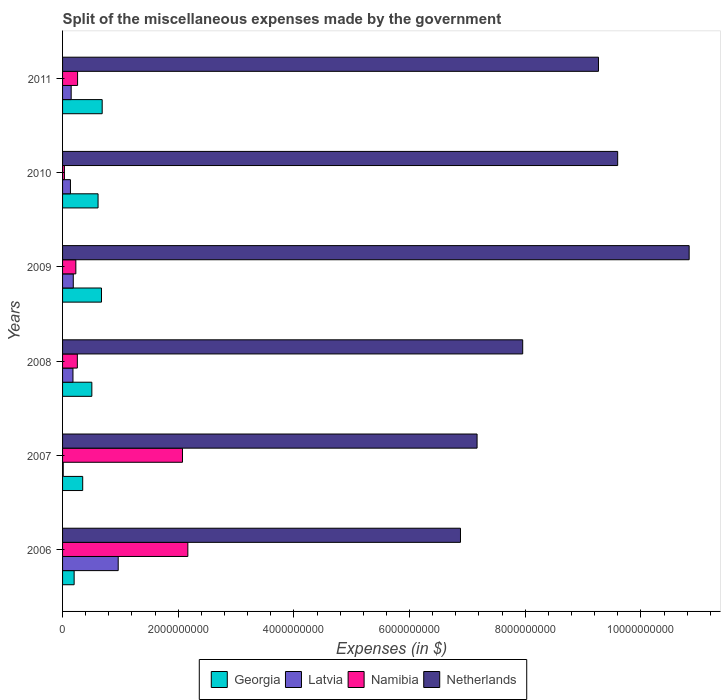How many groups of bars are there?
Your response must be concise. 6. Are the number of bars per tick equal to the number of legend labels?
Keep it short and to the point. Yes. Are the number of bars on each tick of the Y-axis equal?
Provide a succinct answer. Yes. What is the label of the 6th group of bars from the top?
Keep it short and to the point. 2006. In how many cases, is the number of bars for a given year not equal to the number of legend labels?
Your answer should be compact. 0. What is the miscellaneous expenses made by the government in Namibia in 2006?
Offer a terse response. 2.17e+09. Across all years, what is the maximum miscellaneous expenses made by the government in Netherlands?
Ensure brevity in your answer.  1.08e+1. Across all years, what is the minimum miscellaneous expenses made by the government in Netherlands?
Provide a short and direct response. 6.88e+09. In which year was the miscellaneous expenses made by the government in Latvia maximum?
Ensure brevity in your answer.  2006. What is the total miscellaneous expenses made by the government in Netherlands in the graph?
Keep it short and to the point. 5.17e+1. What is the difference between the miscellaneous expenses made by the government in Georgia in 2006 and that in 2008?
Your answer should be very brief. -3.06e+08. What is the difference between the miscellaneous expenses made by the government in Namibia in 2009 and the miscellaneous expenses made by the government in Latvia in 2007?
Your answer should be very brief. 2.18e+08. What is the average miscellaneous expenses made by the government in Georgia per year?
Offer a terse response. 5.04e+08. In the year 2009, what is the difference between the miscellaneous expenses made by the government in Georgia and miscellaneous expenses made by the government in Netherlands?
Give a very brief answer. -1.02e+1. In how many years, is the miscellaneous expenses made by the government in Georgia greater than 6400000000 $?
Offer a very short reply. 0. What is the ratio of the miscellaneous expenses made by the government in Latvia in 2006 to that in 2010?
Keep it short and to the point. 7.06. Is the miscellaneous expenses made by the government in Georgia in 2008 less than that in 2009?
Offer a very short reply. Yes. Is the difference between the miscellaneous expenses made by the government in Georgia in 2010 and 2011 greater than the difference between the miscellaneous expenses made by the government in Netherlands in 2010 and 2011?
Give a very brief answer. No. What is the difference between the highest and the second highest miscellaneous expenses made by the government in Namibia?
Keep it short and to the point. 9.26e+07. What is the difference between the highest and the lowest miscellaneous expenses made by the government in Namibia?
Provide a succinct answer. 2.13e+09. In how many years, is the miscellaneous expenses made by the government in Georgia greater than the average miscellaneous expenses made by the government in Georgia taken over all years?
Your answer should be compact. 4. What does the 4th bar from the top in 2010 represents?
Your response must be concise. Georgia. What does the 3rd bar from the bottom in 2011 represents?
Your answer should be very brief. Namibia. Is it the case that in every year, the sum of the miscellaneous expenses made by the government in Latvia and miscellaneous expenses made by the government in Georgia is greater than the miscellaneous expenses made by the government in Namibia?
Your response must be concise. No. How many bars are there?
Make the answer very short. 24. Are all the bars in the graph horizontal?
Offer a terse response. Yes. How many years are there in the graph?
Offer a very short reply. 6. What is the difference between two consecutive major ticks on the X-axis?
Keep it short and to the point. 2.00e+09. Where does the legend appear in the graph?
Make the answer very short. Bottom center. How many legend labels are there?
Offer a terse response. 4. How are the legend labels stacked?
Give a very brief answer. Horizontal. What is the title of the graph?
Your response must be concise. Split of the miscellaneous expenses made by the government. Does "New Caledonia" appear as one of the legend labels in the graph?
Make the answer very short. No. What is the label or title of the X-axis?
Provide a succinct answer. Expenses (in $). What is the label or title of the Y-axis?
Provide a succinct answer. Years. What is the Expenses (in $) in Georgia in 2006?
Keep it short and to the point. 2.00e+08. What is the Expenses (in $) in Latvia in 2006?
Ensure brevity in your answer.  9.62e+08. What is the Expenses (in $) in Namibia in 2006?
Keep it short and to the point. 2.17e+09. What is the Expenses (in $) in Netherlands in 2006?
Ensure brevity in your answer.  6.88e+09. What is the Expenses (in $) of Georgia in 2007?
Your answer should be very brief. 3.48e+08. What is the Expenses (in $) in Latvia in 2007?
Your answer should be very brief. 1.14e+07. What is the Expenses (in $) of Namibia in 2007?
Offer a terse response. 2.07e+09. What is the Expenses (in $) in Netherlands in 2007?
Offer a very short reply. 7.17e+09. What is the Expenses (in $) in Georgia in 2008?
Offer a terse response. 5.06e+08. What is the Expenses (in $) in Latvia in 2008?
Give a very brief answer. 1.80e+08. What is the Expenses (in $) in Namibia in 2008?
Provide a short and direct response. 2.55e+08. What is the Expenses (in $) in Netherlands in 2008?
Ensure brevity in your answer.  7.96e+09. What is the Expenses (in $) of Georgia in 2009?
Offer a very short reply. 6.73e+08. What is the Expenses (in $) of Latvia in 2009?
Your answer should be very brief. 1.85e+08. What is the Expenses (in $) in Namibia in 2009?
Your answer should be compact. 2.30e+08. What is the Expenses (in $) in Netherlands in 2009?
Ensure brevity in your answer.  1.08e+1. What is the Expenses (in $) of Georgia in 2010?
Provide a succinct answer. 6.14e+08. What is the Expenses (in $) of Latvia in 2010?
Ensure brevity in your answer.  1.36e+08. What is the Expenses (in $) of Namibia in 2010?
Your response must be concise. 3.22e+07. What is the Expenses (in $) of Netherlands in 2010?
Provide a succinct answer. 9.60e+09. What is the Expenses (in $) in Georgia in 2011?
Provide a succinct answer. 6.85e+08. What is the Expenses (in $) of Latvia in 2011?
Your answer should be compact. 1.49e+08. What is the Expenses (in $) of Namibia in 2011?
Offer a terse response. 2.60e+08. What is the Expenses (in $) of Netherlands in 2011?
Offer a very short reply. 9.27e+09. Across all years, what is the maximum Expenses (in $) of Georgia?
Give a very brief answer. 6.85e+08. Across all years, what is the maximum Expenses (in $) in Latvia?
Give a very brief answer. 9.62e+08. Across all years, what is the maximum Expenses (in $) in Namibia?
Give a very brief answer. 2.17e+09. Across all years, what is the maximum Expenses (in $) of Netherlands?
Provide a short and direct response. 1.08e+1. Across all years, what is the minimum Expenses (in $) in Georgia?
Your response must be concise. 2.00e+08. Across all years, what is the minimum Expenses (in $) of Latvia?
Provide a succinct answer. 1.14e+07. Across all years, what is the minimum Expenses (in $) in Namibia?
Offer a very short reply. 3.22e+07. Across all years, what is the minimum Expenses (in $) in Netherlands?
Provide a short and direct response. 6.88e+09. What is the total Expenses (in $) of Georgia in the graph?
Ensure brevity in your answer.  3.03e+09. What is the total Expenses (in $) of Latvia in the graph?
Give a very brief answer. 1.62e+09. What is the total Expenses (in $) in Namibia in the graph?
Your response must be concise. 5.02e+09. What is the total Expenses (in $) in Netherlands in the graph?
Keep it short and to the point. 5.17e+1. What is the difference between the Expenses (in $) of Georgia in 2006 and that in 2007?
Offer a very short reply. -1.48e+08. What is the difference between the Expenses (in $) in Latvia in 2006 and that in 2007?
Give a very brief answer. 9.51e+08. What is the difference between the Expenses (in $) of Namibia in 2006 and that in 2007?
Provide a short and direct response. 9.26e+07. What is the difference between the Expenses (in $) in Netherlands in 2006 and that in 2007?
Your answer should be compact. -2.87e+08. What is the difference between the Expenses (in $) in Georgia in 2006 and that in 2008?
Keep it short and to the point. -3.06e+08. What is the difference between the Expenses (in $) in Latvia in 2006 and that in 2008?
Ensure brevity in your answer.  7.82e+08. What is the difference between the Expenses (in $) of Namibia in 2006 and that in 2008?
Your answer should be compact. 1.91e+09. What is the difference between the Expenses (in $) of Netherlands in 2006 and that in 2008?
Give a very brief answer. -1.08e+09. What is the difference between the Expenses (in $) in Georgia in 2006 and that in 2009?
Offer a terse response. -4.73e+08. What is the difference between the Expenses (in $) of Latvia in 2006 and that in 2009?
Keep it short and to the point. 7.77e+08. What is the difference between the Expenses (in $) in Namibia in 2006 and that in 2009?
Your answer should be compact. 1.94e+09. What is the difference between the Expenses (in $) of Netherlands in 2006 and that in 2009?
Your answer should be very brief. -3.95e+09. What is the difference between the Expenses (in $) of Georgia in 2006 and that in 2010?
Offer a terse response. -4.14e+08. What is the difference between the Expenses (in $) in Latvia in 2006 and that in 2010?
Provide a short and direct response. 8.26e+08. What is the difference between the Expenses (in $) of Namibia in 2006 and that in 2010?
Give a very brief answer. 2.13e+09. What is the difference between the Expenses (in $) in Netherlands in 2006 and that in 2010?
Offer a terse response. -2.72e+09. What is the difference between the Expenses (in $) in Georgia in 2006 and that in 2011?
Ensure brevity in your answer.  -4.85e+08. What is the difference between the Expenses (in $) in Latvia in 2006 and that in 2011?
Offer a terse response. 8.13e+08. What is the difference between the Expenses (in $) in Namibia in 2006 and that in 2011?
Your answer should be compact. 1.91e+09. What is the difference between the Expenses (in $) in Netherlands in 2006 and that in 2011?
Keep it short and to the point. -2.39e+09. What is the difference between the Expenses (in $) in Georgia in 2007 and that in 2008?
Your response must be concise. -1.58e+08. What is the difference between the Expenses (in $) of Latvia in 2007 and that in 2008?
Ensure brevity in your answer.  -1.69e+08. What is the difference between the Expenses (in $) of Namibia in 2007 and that in 2008?
Provide a succinct answer. 1.82e+09. What is the difference between the Expenses (in $) of Netherlands in 2007 and that in 2008?
Give a very brief answer. -7.89e+08. What is the difference between the Expenses (in $) of Georgia in 2007 and that in 2009?
Keep it short and to the point. -3.25e+08. What is the difference between the Expenses (in $) of Latvia in 2007 and that in 2009?
Ensure brevity in your answer.  -1.74e+08. What is the difference between the Expenses (in $) of Namibia in 2007 and that in 2009?
Your response must be concise. 1.84e+09. What is the difference between the Expenses (in $) of Netherlands in 2007 and that in 2009?
Provide a succinct answer. -3.67e+09. What is the difference between the Expenses (in $) of Georgia in 2007 and that in 2010?
Your answer should be very brief. -2.66e+08. What is the difference between the Expenses (in $) of Latvia in 2007 and that in 2010?
Your response must be concise. -1.25e+08. What is the difference between the Expenses (in $) of Namibia in 2007 and that in 2010?
Offer a terse response. 2.04e+09. What is the difference between the Expenses (in $) in Netherlands in 2007 and that in 2010?
Your response must be concise. -2.43e+09. What is the difference between the Expenses (in $) of Georgia in 2007 and that in 2011?
Keep it short and to the point. -3.37e+08. What is the difference between the Expenses (in $) in Latvia in 2007 and that in 2011?
Provide a succinct answer. -1.37e+08. What is the difference between the Expenses (in $) of Namibia in 2007 and that in 2011?
Your response must be concise. 1.81e+09. What is the difference between the Expenses (in $) in Netherlands in 2007 and that in 2011?
Provide a succinct answer. -2.10e+09. What is the difference between the Expenses (in $) of Georgia in 2008 and that in 2009?
Make the answer very short. -1.67e+08. What is the difference between the Expenses (in $) in Latvia in 2008 and that in 2009?
Keep it short and to the point. -5.15e+06. What is the difference between the Expenses (in $) in Namibia in 2008 and that in 2009?
Your response must be concise. 2.59e+07. What is the difference between the Expenses (in $) of Netherlands in 2008 and that in 2009?
Offer a terse response. -2.88e+09. What is the difference between the Expenses (in $) in Georgia in 2008 and that in 2010?
Keep it short and to the point. -1.08e+08. What is the difference between the Expenses (in $) in Latvia in 2008 and that in 2010?
Offer a terse response. 4.36e+07. What is the difference between the Expenses (in $) of Namibia in 2008 and that in 2010?
Provide a short and direct response. 2.23e+08. What is the difference between the Expenses (in $) in Netherlands in 2008 and that in 2010?
Ensure brevity in your answer.  -1.64e+09. What is the difference between the Expenses (in $) of Georgia in 2008 and that in 2011?
Your answer should be very brief. -1.79e+08. What is the difference between the Expenses (in $) in Latvia in 2008 and that in 2011?
Provide a short and direct response. 3.12e+07. What is the difference between the Expenses (in $) of Namibia in 2008 and that in 2011?
Keep it short and to the point. -4.06e+06. What is the difference between the Expenses (in $) of Netherlands in 2008 and that in 2011?
Offer a terse response. -1.31e+09. What is the difference between the Expenses (in $) in Georgia in 2009 and that in 2010?
Ensure brevity in your answer.  5.92e+07. What is the difference between the Expenses (in $) of Latvia in 2009 and that in 2010?
Keep it short and to the point. 4.88e+07. What is the difference between the Expenses (in $) in Namibia in 2009 and that in 2010?
Your response must be concise. 1.97e+08. What is the difference between the Expenses (in $) in Netherlands in 2009 and that in 2010?
Ensure brevity in your answer.  1.24e+09. What is the difference between the Expenses (in $) in Georgia in 2009 and that in 2011?
Offer a very short reply. -1.21e+07. What is the difference between the Expenses (in $) in Latvia in 2009 and that in 2011?
Offer a terse response. 3.63e+07. What is the difference between the Expenses (in $) in Namibia in 2009 and that in 2011?
Your response must be concise. -2.99e+07. What is the difference between the Expenses (in $) of Netherlands in 2009 and that in 2011?
Give a very brief answer. 1.57e+09. What is the difference between the Expenses (in $) of Georgia in 2010 and that in 2011?
Your answer should be very brief. -7.13e+07. What is the difference between the Expenses (in $) of Latvia in 2010 and that in 2011?
Offer a terse response. -1.25e+07. What is the difference between the Expenses (in $) of Namibia in 2010 and that in 2011?
Keep it short and to the point. -2.27e+08. What is the difference between the Expenses (in $) of Netherlands in 2010 and that in 2011?
Offer a very short reply. 3.32e+08. What is the difference between the Expenses (in $) of Georgia in 2006 and the Expenses (in $) of Latvia in 2007?
Your response must be concise. 1.89e+08. What is the difference between the Expenses (in $) of Georgia in 2006 and the Expenses (in $) of Namibia in 2007?
Offer a terse response. -1.87e+09. What is the difference between the Expenses (in $) in Georgia in 2006 and the Expenses (in $) in Netherlands in 2007?
Keep it short and to the point. -6.97e+09. What is the difference between the Expenses (in $) in Latvia in 2006 and the Expenses (in $) in Namibia in 2007?
Your response must be concise. -1.11e+09. What is the difference between the Expenses (in $) in Latvia in 2006 and the Expenses (in $) in Netherlands in 2007?
Provide a succinct answer. -6.20e+09. What is the difference between the Expenses (in $) in Namibia in 2006 and the Expenses (in $) in Netherlands in 2007?
Provide a succinct answer. -5.00e+09. What is the difference between the Expenses (in $) in Georgia in 2006 and the Expenses (in $) in Namibia in 2008?
Offer a very short reply. -5.55e+07. What is the difference between the Expenses (in $) in Georgia in 2006 and the Expenses (in $) in Netherlands in 2008?
Offer a terse response. -7.76e+09. What is the difference between the Expenses (in $) in Latvia in 2006 and the Expenses (in $) in Namibia in 2008?
Your response must be concise. 7.07e+08. What is the difference between the Expenses (in $) of Latvia in 2006 and the Expenses (in $) of Netherlands in 2008?
Your response must be concise. -6.99e+09. What is the difference between the Expenses (in $) in Namibia in 2006 and the Expenses (in $) in Netherlands in 2008?
Offer a terse response. -5.79e+09. What is the difference between the Expenses (in $) in Georgia in 2006 and the Expenses (in $) in Latvia in 2009?
Give a very brief answer. 1.49e+07. What is the difference between the Expenses (in $) of Georgia in 2006 and the Expenses (in $) of Namibia in 2009?
Your response must be concise. -2.96e+07. What is the difference between the Expenses (in $) of Georgia in 2006 and the Expenses (in $) of Netherlands in 2009?
Your answer should be compact. -1.06e+1. What is the difference between the Expenses (in $) of Latvia in 2006 and the Expenses (in $) of Namibia in 2009?
Provide a short and direct response. 7.33e+08. What is the difference between the Expenses (in $) in Latvia in 2006 and the Expenses (in $) in Netherlands in 2009?
Your answer should be compact. -9.87e+09. What is the difference between the Expenses (in $) of Namibia in 2006 and the Expenses (in $) of Netherlands in 2009?
Your response must be concise. -8.67e+09. What is the difference between the Expenses (in $) in Georgia in 2006 and the Expenses (in $) in Latvia in 2010?
Your answer should be compact. 6.36e+07. What is the difference between the Expenses (in $) in Georgia in 2006 and the Expenses (in $) in Namibia in 2010?
Provide a succinct answer. 1.68e+08. What is the difference between the Expenses (in $) of Georgia in 2006 and the Expenses (in $) of Netherlands in 2010?
Offer a very short reply. -9.40e+09. What is the difference between the Expenses (in $) of Latvia in 2006 and the Expenses (in $) of Namibia in 2010?
Offer a terse response. 9.30e+08. What is the difference between the Expenses (in $) of Latvia in 2006 and the Expenses (in $) of Netherlands in 2010?
Make the answer very short. -8.64e+09. What is the difference between the Expenses (in $) in Namibia in 2006 and the Expenses (in $) in Netherlands in 2010?
Your response must be concise. -7.43e+09. What is the difference between the Expenses (in $) in Georgia in 2006 and the Expenses (in $) in Latvia in 2011?
Your response must be concise. 5.12e+07. What is the difference between the Expenses (in $) of Georgia in 2006 and the Expenses (in $) of Namibia in 2011?
Offer a terse response. -5.95e+07. What is the difference between the Expenses (in $) in Georgia in 2006 and the Expenses (in $) in Netherlands in 2011?
Your answer should be compact. -9.07e+09. What is the difference between the Expenses (in $) in Latvia in 2006 and the Expenses (in $) in Namibia in 2011?
Your answer should be very brief. 7.03e+08. What is the difference between the Expenses (in $) in Latvia in 2006 and the Expenses (in $) in Netherlands in 2011?
Your answer should be very brief. -8.30e+09. What is the difference between the Expenses (in $) in Namibia in 2006 and the Expenses (in $) in Netherlands in 2011?
Your answer should be compact. -7.10e+09. What is the difference between the Expenses (in $) in Georgia in 2007 and the Expenses (in $) in Latvia in 2008?
Provide a succinct answer. 1.68e+08. What is the difference between the Expenses (in $) in Georgia in 2007 and the Expenses (in $) in Namibia in 2008?
Keep it short and to the point. 9.27e+07. What is the difference between the Expenses (in $) of Georgia in 2007 and the Expenses (in $) of Netherlands in 2008?
Your response must be concise. -7.61e+09. What is the difference between the Expenses (in $) in Latvia in 2007 and the Expenses (in $) in Namibia in 2008?
Provide a succinct answer. -2.44e+08. What is the difference between the Expenses (in $) of Latvia in 2007 and the Expenses (in $) of Netherlands in 2008?
Ensure brevity in your answer.  -7.94e+09. What is the difference between the Expenses (in $) in Namibia in 2007 and the Expenses (in $) in Netherlands in 2008?
Your answer should be very brief. -5.88e+09. What is the difference between the Expenses (in $) of Georgia in 2007 and the Expenses (in $) of Latvia in 2009?
Make the answer very short. 1.63e+08. What is the difference between the Expenses (in $) in Georgia in 2007 and the Expenses (in $) in Namibia in 2009?
Give a very brief answer. 1.19e+08. What is the difference between the Expenses (in $) of Georgia in 2007 and the Expenses (in $) of Netherlands in 2009?
Ensure brevity in your answer.  -1.05e+1. What is the difference between the Expenses (in $) in Latvia in 2007 and the Expenses (in $) in Namibia in 2009?
Provide a succinct answer. -2.18e+08. What is the difference between the Expenses (in $) of Latvia in 2007 and the Expenses (in $) of Netherlands in 2009?
Your response must be concise. -1.08e+1. What is the difference between the Expenses (in $) in Namibia in 2007 and the Expenses (in $) in Netherlands in 2009?
Provide a short and direct response. -8.76e+09. What is the difference between the Expenses (in $) of Georgia in 2007 and the Expenses (in $) of Latvia in 2010?
Make the answer very short. 2.12e+08. What is the difference between the Expenses (in $) in Georgia in 2007 and the Expenses (in $) in Namibia in 2010?
Keep it short and to the point. 3.16e+08. What is the difference between the Expenses (in $) of Georgia in 2007 and the Expenses (in $) of Netherlands in 2010?
Offer a very short reply. -9.25e+09. What is the difference between the Expenses (in $) in Latvia in 2007 and the Expenses (in $) in Namibia in 2010?
Give a very brief answer. -2.08e+07. What is the difference between the Expenses (in $) of Latvia in 2007 and the Expenses (in $) of Netherlands in 2010?
Provide a succinct answer. -9.59e+09. What is the difference between the Expenses (in $) in Namibia in 2007 and the Expenses (in $) in Netherlands in 2010?
Give a very brief answer. -7.52e+09. What is the difference between the Expenses (in $) in Georgia in 2007 and the Expenses (in $) in Latvia in 2011?
Make the answer very short. 1.99e+08. What is the difference between the Expenses (in $) in Georgia in 2007 and the Expenses (in $) in Namibia in 2011?
Your answer should be very brief. 8.87e+07. What is the difference between the Expenses (in $) of Georgia in 2007 and the Expenses (in $) of Netherlands in 2011?
Your answer should be compact. -8.92e+09. What is the difference between the Expenses (in $) of Latvia in 2007 and the Expenses (in $) of Namibia in 2011?
Provide a succinct answer. -2.48e+08. What is the difference between the Expenses (in $) of Latvia in 2007 and the Expenses (in $) of Netherlands in 2011?
Provide a succinct answer. -9.25e+09. What is the difference between the Expenses (in $) of Namibia in 2007 and the Expenses (in $) of Netherlands in 2011?
Your answer should be very brief. -7.19e+09. What is the difference between the Expenses (in $) of Georgia in 2008 and the Expenses (in $) of Latvia in 2009?
Provide a succinct answer. 3.21e+08. What is the difference between the Expenses (in $) in Georgia in 2008 and the Expenses (in $) in Namibia in 2009?
Ensure brevity in your answer.  2.77e+08. What is the difference between the Expenses (in $) in Georgia in 2008 and the Expenses (in $) in Netherlands in 2009?
Ensure brevity in your answer.  -1.03e+1. What is the difference between the Expenses (in $) in Latvia in 2008 and the Expenses (in $) in Namibia in 2009?
Offer a very short reply. -4.96e+07. What is the difference between the Expenses (in $) of Latvia in 2008 and the Expenses (in $) of Netherlands in 2009?
Provide a succinct answer. -1.07e+1. What is the difference between the Expenses (in $) of Namibia in 2008 and the Expenses (in $) of Netherlands in 2009?
Offer a terse response. -1.06e+1. What is the difference between the Expenses (in $) of Georgia in 2008 and the Expenses (in $) of Latvia in 2010?
Your answer should be compact. 3.70e+08. What is the difference between the Expenses (in $) in Georgia in 2008 and the Expenses (in $) in Namibia in 2010?
Keep it short and to the point. 4.74e+08. What is the difference between the Expenses (in $) of Georgia in 2008 and the Expenses (in $) of Netherlands in 2010?
Your answer should be very brief. -9.09e+09. What is the difference between the Expenses (in $) in Latvia in 2008 and the Expenses (in $) in Namibia in 2010?
Ensure brevity in your answer.  1.48e+08. What is the difference between the Expenses (in $) of Latvia in 2008 and the Expenses (in $) of Netherlands in 2010?
Keep it short and to the point. -9.42e+09. What is the difference between the Expenses (in $) in Namibia in 2008 and the Expenses (in $) in Netherlands in 2010?
Provide a succinct answer. -9.34e+09. What is the difference between the Expenses (in $) in Georgia in 2008 and the Expenses (in $) in Latvia in 2011?
Offer a terse response. 3.57e+08. What is the difference between the Expenses (in $) of Georgia in 2008 and the Expenses (in $) of Namibia in 2011?
Your answer should be very brief. 2.47e+08. What is the difference between the Expenses (in $) in Georgia in 2008 and the Expenses (in $) in Netherlands in 2011?
Provide a short and direct response. -8.76e+09. What is the difference between the Expenses (in $) of Latvia in 2008 and the Expenses (in $) of Namibia in 2011?
Ensure brevity in your answer.  -7.95e+07. What is the difference between the Expenses (in $) of Latvia in 2008 and the Expenses (in $) of Netherlands in 2011?
Keep it short and to the point. -9.09e+09. What is the difference between the Expenses (in $) in Namibia in 2008 and the Expenses (in $) in Netherlands in 2011?
Ensure brevity in your answer.  -9.01e+09. What is the difference between the Expenses (in $) of Georgia in 2009 and the Expenses (in $) of Latvia in 2010?
Keep it short and to the point. 5.37e+08. What is the difference between the Expenses (in $) of Georgia in 2009 and the Expenses (in $) of Namibia in 2010?
Keep it short and to the point. 6.41e+08. What is the difference between the Expenses (in $) in Georgia in 2009 and the Expenses (in $) in Netherlands in 2010?
Make the answer very short. -8.93e+09. What is the difference between the Expenses (in $) of Latvia in 2009 and the Expenses (in $) of Namibia in 2010?
Provide a short and direct response. 1.53e+08. What is the difference between the Expenses (in $) of Latvia in 2009 and the Expenses (in $) of Netherlands in 2010?
Your response must be concise. -9.41e+09. What is the difference between the Expenses (in $) in Namibia in 2009 and the Expenses (in $) in Netherlands in 2010?
Keep it short and to the point. -9.37e+09. What is the difference between the Expenses (in $) of Georgia in 2009 and the Expenses (in $) of Latvia in 2011?
Provide a short and direct response. 5.24e+08. What is the difference between the Expenses (in $) of Georgia in 2009 and the Expenses (in $) of Namibia in 2011?
Keep it short and to the point. 4.13e+08. What is the difference between the Expenses (in $) in Georgia in 2009 and the Expenses (in $) in Netherlands in 2011?
Give a very brief answer. -8.59e+09. What is the difference between the Expenses (in $) in Latvia in 2009 and the Expenses (in $) in Namibia in 2011?
Your answer should be very brief. -7.44e+07. What is the difference between the Expenses (in $) in Latvia in 2009 and the Expenses (in $) in Netherlands in 2011?
Give a very brief answer. -9.08e+09. What is the difference between the Expenses (in $) of Namibia in 2009 and the Expenses (in $) of Netherlands in 2011?
Your response must be concise. -9.04e+09. What is the difference between the Expenses (in $) of Georgia in 2010 and the Expenses (in $) of Latvia in 2011?
Your answer should be very brief. 4.65e+08. What is the difference between the Expenses (in $) in Georgia in 2010 and the Expenses (in $) in Namibia in 2011?
Your response must be concise. 3.54e+08. What is the difference between the Expenses (in $) of Georgia in 2010 and the Expenses (in $) of Netherlands in 2011?
Your response must be concise. -8.65e+09. What is the difference between the Expenses (in $) of Latvia in 2010 and the Expenses (in $) of Namibia in 2011?
Provide a short and direct response. -1.23e+08. What is the difference between the Expenses (in $) of Latvia in 2010 and the Expenses (in $) of Netherlands in 2011?
Offer a terse response. -9.13e+09. What is the difference between the Expenses (in $) in Namibia in 2010 and the Expenses (in $) in Netherlands in 2011?
Provide a short and direct response. -9.23e+09. What is the average Expenses (in $) in Georgia per year?
Offer a terse response. 5.04e+08. What is the average Expenses (in $) of Latvia per year?
Make the answer very short. 2.71e+08. What is the average Expenses (in $) of Namibia per year?
Your answer should be very brief. 8.36e+08. What is the average Expenses (in $) in Netherlands per year?
Keep it short and to the point. 8.62e+09. In the year 2006, what is the difference between the Expenses (in $) in Georgia and Expenses (in $) in Latvia?
Offer a very short reply. -7.62e+08. In the year 2006, what is the difference between the Expenses (in $) in Georgia and Expenses (in $) in Namibia?
Provide a succinct answer. -1.97e+09. In the year 2006, what is the difference between the Expenses (in $) of Georgia and Expenses (in $) of Netherlands?
Your answer should be very brief. -6.68e+09. In the year 2006, what is the difference between the Expenses (in $) of Latvia and Expenses (in $) of Namibia?
Your answer should be very brief. -1.20e+09. In the year 2006, what is the difference between the Expenses (in $) of Latvia and Expenses (in $) of Netherlands?
Your answer should be compact. -5.92e+09. In the year 2006, what is the difference between the Expenses (in $) of Namibia and Expenses (in $) of Netherlands?
Provide a succinct answer. -4.71e+09. In the year 2007, what is the difference between the Expenses (in $) of Georgia and Expenses (in $) of Latvia?
Ensure brevity in your answer.  3.37e+08. In the year 2007, what is the difference between the Expenses (in $) in Georgia and Expenses (in $) in Namibia?
Offer a terse response. -1.73e+09. In the year 2007, what is the difference between the Expenses (in $) of Georgia and Expenses (in $) of Netherlands?
Give a very brief answer. -6.82e+09. In the year 2007, what is the difference between the Expenses (in $) of Latvia and Expenses (in $) of Namibia?
Offer a very short reply. -2.06e+09. In the year 2007, what is the difference between the Expenses (in $) of Latvia and Expenses (in $) of Netherlands?
Provide a short and direct response. -7.16e+09. In the year 2007, what is the difference between the Expenses (in $) of Namibia and Expenses (in $) of Netherlands?
Keep it short and to the point. -5.09e+09. In the year 2008, what is the difference between the Expenses (in $) in Georgia and Expenses (in $) in Latvia?
Your response must be concise. 3.26e+08. In the year 2008, what is the difference between the Expenses (in $) of Georgia and Expenses (in $) of Namibia?
Your response must be concise. 2.51e+08. In the year 2008, what is the difference between the Expenses (in $) of Georgia and Expenses (in $) of Netherlands?
Keep it short and to the point. -7.45e+09. In the year 2008, what is the difference between the Expenses (in $) in Latvia and Expenses (in $) in Namibia?
Provide a short and direct response. -7.55e+07. In the year 2008, what is the difference between the Expenses (in $) in Latvia and Expenses (in $) in Netherlands?
Provide a succinct answer. -7.78e+09. In the year 2008, what is the difference between the Expenses (in $) of Namibia and Expenses (in $) of Netherlands?
Provide a succinct answer. -7.70e+09. In the year 2009, what is the difference between the Expenses (in $) in Georgia and Expenses (in $) in Latvia?
Keep it short and to the point. 4.88e+08. In the year 2009, what is the difference between the Expenses (in $) in Georgia and Expenses (in $) in Namibia?
Offer a terse response. 4.43e+08. In the year 2009, what is the difference between the Expenses (in $) in Georgia and Expenses (in $) in Netherlands?
Provide a short and direct response. -1.02e+1. In the year 2009, what is the difference between the Expenses (in $) of Latvia and Expenses (in $) of Namibia?
Offer a terse response. -4.44e+07. In the year 2009, what is the difference between the Expenses (in $) of Latvia and Expenses (in $) of Netherlands?
Ensure brevity in your answer.  -1.06e+1. In the year 2009, what is the difference between the Expenses (in $) in Namibia and Expenses (in $) in Netherlands?
Offer a terse response. -1.06e+1. In the year 2010, what is the difference between the Expenses (in $) of Georgia and Expenses (in $) of Latvia?
Ensure brevity in your answer.  4.77e+08. In the year 2010, what is the difference between the Expenses (in $) in Georgia and Expenses (in $) in Namibia?
Provide a short and direct response. 5.82e+08. In the year 2010, what is the difference between the Expenses (in $) in Georgia and Expenses (in $) in Netherlands?
Give a very brief answer. -8.98e+09. In the year 2010, what is the difference between the Expenses (in $) of Latvia and Expenses (in $) of Namibia?
Provide a short and direct response. 1.04e+08. In the year 2010, what is the difference between the Expenses (in $) of Latvia and Expenses (in $) of Netherlands?
Offer a terse response. -9.46e+09. In the year 2010, what is the difference between the Expenses (in $) in Namibia and Expenses (in $) in Netherlands?
Offer a very short reply. -9.57e+09. In the year 2011, what is the difference between the Expenses (in $) of Georgia and Expenses (in $) of Latvia?
Ensure brevity in your answer.  5.36e+08. In the year 2011, what is the difference between the Expenses (in $) in Georgia and Expenses (in $) in Namibia?
Your response must be concise. 4.25e+08. In the year 2011, what is the difference between the Expenses (in $) in Georgia and Expenses (in $) in Netherlands?
Give a very brief answer. -8.58e+09. In the year 2011, what is the difference between the Expenses (in $) of Latvia and Expenses (in $) of Namibia?
Provide a succinct answer. -1.11e+08. In the year 2011, what is the difference between the Expenses (in $) in Latvia and Expenses (in $) in Netherlands?
Give a very brief answer. -9.12e+09. In the year 2011, what is the difference between the Expenses (in $) in Namibia and Expenses (in $) in Netherlands?
Make the answer very short. -9.01e+09. What is the ratio of the Expenses (in $) in Georgia in 2006 to that in 2007?
Your answer should be very brief. 0.57. What is the ratio of the Expenses (in $) in Latvia in 2006 to that in 2007?
Your answer should be compact. 84.39. What is the ratio of the Expenses (in $) of Namibia in 2006 to that in 2007?
Provide a succinct answer. 1.04. What is the ratio of the Expenses (in $) of Georgia in 2006 to that in 2008?
Provide a succinct answer. 0.4. What is the ratio of the Expenses (in $) of Latvia in 2006 to that in 2008?
Your answer should be compact. 5.34. What is the ratio of the Expenses (in $) in Namibia in 2006 to that in 2008?
Provide a short and direct response. 8.48. What is the ratio of the Expenses (in $) in Netherlands in 2006 to that in 2008?
Give a very brief answer. 0.86. What is the ratio of the Expenses (in $) in Georgia in 2006 to that in 2009?
Ensure brevity in your answer.  0.3. What is the ratio of the Expenses (in $) in Latvia in 2006 to that in 2009?
Your answer should be compact. 5.2. What is the ratio of the Expenses (in $) of Namibia in 2006 to that in 2009?
Give a very brief answer. 9.43. What is the ratio of the Expenses (in $) in Netherlands in 2006 to that in 2009?
Provide a short and direct response. 0.64. What is the ratio of the Expenses (in $) in Georgia in 2006 to that in 2010?
Provide a succinct answer. 0.33. What is the ratio of the Expenses (in $) of Latvia in 2006 to that in 2010?
Provide a succinct answer. 7.06. What is the ratio of the Expenses (in $) of Namibia in 2006 to that in 2010?
Make the answer very short. 67.31. What is the ratio of the Expenses (in $) in Netherlands in 2006 to that in 2010?
Offer a terse response. 0.72. What is the ratio of the Expenses (in $) of Georgia in 2006 to that in 2011?
Ensure brevity in your answer.  0.29. What is the ratio of the Expenses (in $) in Latvia in 2006 to that in 2011?
Make the answer very short. 6.46. What is the ratio of the Expenses (in $) in Namibia in 2006 to that in 2011?
Offer a terse response. 8.35. What is the ratio of the Expenses (in $) of Netherlands in 2006 to that in 2011?
Provide a succinct answer. 0.74. What is the ratio of the Expenses (in $) of Georgia in 2007 to that in 2008?
Keep it short and to the point. 0.69. What is the ratio of the Expenses (in $) of Latvia in 2007 to that in 2008?
Keep it short and to the point. 0.06. What is the ratio of the Expenses (in $) of Namibia in 2007 to that in 2008?
Your response must be concise. 8.12. What is the ratio of the Expenses (in $) in Netherlands in 2007 to that in 2008?
Provide a short and direct response. 0.9. What is the ratio of the Expenses (in $) in Georgia in 2007 to that in 2009?
Provide a succinct answer. 0.52. What is the ratio of the Expenses (in $) in Latvia in 2007 to that in 2009?
Give a very brief answer. 0.06. What is the ratio of the Expenses (in $) in Namibia in 2007 to that in 2009?
Give a very brief answer. 9.03. What is the ratio of the Expenses (in $) of Netherlands in 2007 to that in 2009?
Provide a short and direct response. 0.66. What is the ratio of the Expenses (in $) of Georgia in 2007 to that in 2010?
Offer a very short reply. 0.57. What is the ratio of the Expenses (in $) of Latvia in 2007 to that in 2010?
Ensure brevity in your answer.  0.08. What is the ratio of the Expenses (in $) of Namibia in 2007 to that in 2010?
Ensure brevity in your answer.  64.43. What is the ratio of the Expenses (in $) of Netherlands in 2007 to that in 2010?
Your answer should be compact. 0.75. What is the ratio of the Expenses (in $) of Georgia in 2007 to that in 2011?
Ensure brevity in your answer.  0.51. What is the ratio of the Expenses (in $) of Latvia in 2007 to that in 2011?
Provide a succinct answer. 0.08. What is the ratio of the Expenses (in $) of Namibia in 2007 to that in 2011?
Give a very brief answer. 7.99. What is the ratio of the Expenses (in $) of Netherlands in 2007 to that in 2011?
Keep it short and to the point. 0.77. What is the ratio of the Expenses (in $) of Georgia in 2008 to that in 2009?
Your answer should be very brief. 0.75. What is the ratio of the Expenses (in $) of Latvia in 2008 to that in 2009?
Your answer should be compact. 0.97. What is the ratio of the Expenses (in $) in Namibia in 2008 to that in 2009?
Your answer should be compact. 1.11. What is the ratio of the Expenses (in $) of Netherlands in 2008 to that in 2009?
Your answer should be compact. 0.73. What is the ratio of the Expenses (in $) in Georgia in 2008 to that in 2010?
Your answer should be compact. 0.82. What is the ratio of the Expenses (in $) of Latvia in 2008 to that in 2010?
Your answer should be compact. 1.32. What is the ratio of the Expenses (in $) in Namibia in 2008 to that in 2010?
Ensure brevity in your answer.  7.94. What is the ratio of the Expenses (in $) in Netherlands in 2008 to that in 2010?
Make the answer very short. 0.83. What is the ratio of the Expenses (in $) of Georgia in 2008 to that in 2011?
Keep it short and to the point. 0.74. What is the ratio of the Expenses (in $) of Latvia in 2008 to that in 2011?
Give a very brief answer. 1.21. What is the ratio of the Expenses (in $) in Namibia in 2008 to that in 2011?
Make the answer very short. 0.98. What is the ratio of the Expenses (in $) in Netherlands in 2008 to that in 2011?
Your answer should be compact. 0.86. What is the ratio of the Expenses (in $) in Georgia in 2009 to that in 2010?
Your response must be concise. 1.1. What is the ratio of the Expenses (in $) of Latvia in 2009 to that in 2010?
Keep it short and to the point. 1.36. What is the ratio of the Expenses (in $) of Namibia in 2009 to that in 2010?
Keep it short and to the point. 7.13. What is the ratio of the Expenses (in $) in Netherlands in 2009 to that in 2010?
Give a very brief answer. 1.13. What is the ratio of the Expenses (in $) in Georgia in 2009 to that in 2011?
Give a very brief answer. 0.98. What is the ratio of the Expenses (in $) in Latvia in 2009 to that in 2011?
Offer a very short reply. 1.24. What is the ratio of the Expenses (in $) in Namibia in 2009 to that in 2011?
Provide a short and direct response. 0.88. What is the ratio of the Expenses (in $) in Netherlands in 2009 to that in 2011?
Offer a terse response. 1.17. What is the ratio of the Expenses (in $) in Georgia in 2010 to that in 2011?
Your answer should be compact. 0.9. What is the ratio of the Expenses (in $) in Latvia in 2010 to that in 2011?
Provide a succinct answer. 0.92. What is the ratio of the Expenses (in $) in Namibia in 2010 to that in 2011?
Your response must be concise. 0.12. What is the ratio of the Expenses (in $) of Netherlands in 2010 to that in 2011?
Your answer should be compact. 1.04. What is the difference between the highest and the second highest Expenses (in $) in Georgia?
Ensure brevity in your answer.  1.21e+07. What is the difference between the highest and the second highest Expenses (in $) of Latvia?
Provide a short and direct response. 7.77e+08. What is the difference between the highest and the second highest Expenses (in $) of Namibia?
Ensure brevity in your answer.  9.26e+07. What is the difference between the highest and the second highest Expenses (in $) in Netherlands?
Your answer should be compact. 1.24e+09. What is the difference between the highest and the lowest Expenses (in $) of Georgia?
Offer a very short reply. 4.85e+08. What is the difference between the highest and the lowest Expenses (in $) in Latvia?
Give a very brief answer. 9.51e+08. What is the difference between the highest and the lowest Expenses (in $) in Namibia?
Offer a terse response. 2.13e+09. What is the difference between the highest and the lowest Expenses (in $) of Netherlands?
Your answer should be very brief. 3.95e+09. 